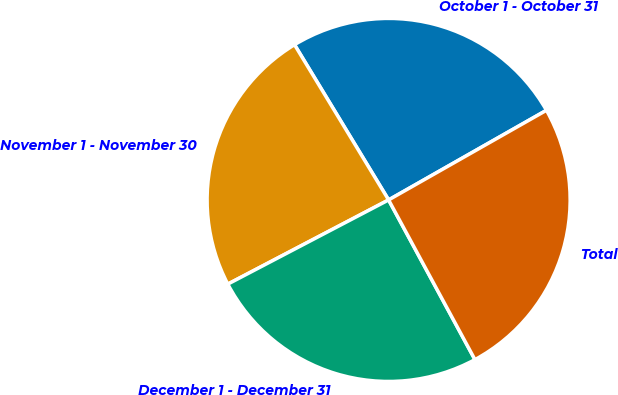Convert chart. <chart><loc_0><loc_0><loc_500><loc_500><pie_chart><fcel>October 1 - October 31<fcel>November 1 - November 30<fcel>December 1 - December 31<fcel>Total<nl><fcel>25.45%<fcel>24.0%<fcel>25.21%<fcel>25.33%<nl></chart> 